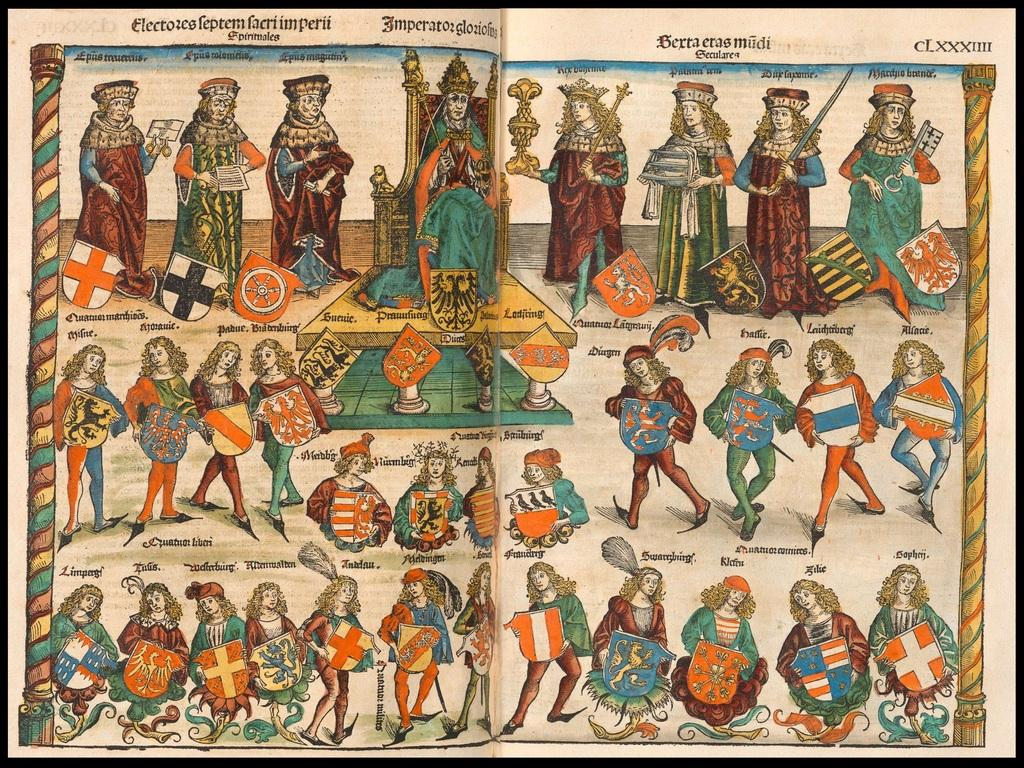What is the main subject of the image? The main subject of the image is a paper. What is depicted on the paper? The paper contains paintings. Are there any words or letters on the paper? Yes, there is text on the paper. What time of day is depicted in the church scene on the paper? There is no church scene depicted on the paper, and therefore no time of day can be determined. Can you tell me how many drawers are visible on the paper? There are no drawers depicted on the paper; it contains paintings and text. 